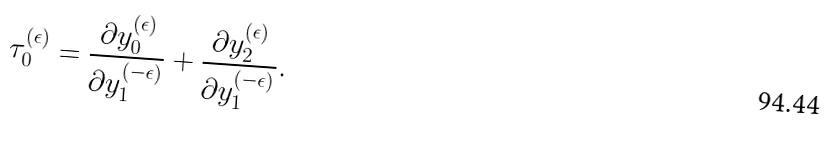Convert formula to latex. <formula><loc_0><loc_0><loc_500><loc_500>\tau ^ { ( \epsilon ) } _ { 0 } = \frac { \partial y _ { 0 } ^ { ( \epsilon ) } } { \partial y _ { 1 } ^ { ( - \epsilon ) } } + \frac { \partial y _ { 2 } ^ { ( \epsilon ) } } { \partial y _ { 1 } ^ { ( - \epsilon ) } } .</formula> 